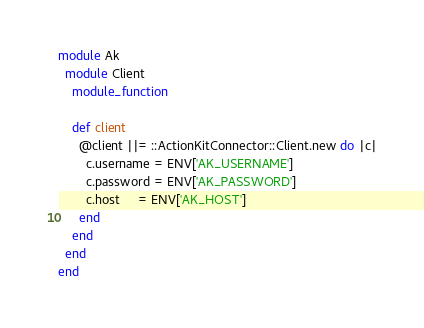Convert code to text. <code><loc_0><loc_0><loc_500><loc_500><_Ruby_>module Ak
  module Client
    module_function

    def client
      @client ||= ::ActionKitConnector::Client.new do |c|
        c.username = ENV['AK_USERNAME']
        c.password = ENV['AK_PASSWORD']
        c.host     = ENV['AK_HOST']
      end
    end
  end
end

</code> 